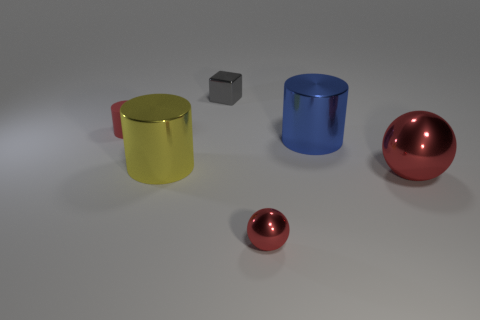What color is the cube that is the same size as the red rubber object?
Provide a succinct answer. Gray. How many things are in front of the tiny metallic block and on the left side of the big ball?
Your response must be concise. 4. What is the small cylinder made of?
Ensure brevity in your answer.  Rubber. How many things are blue matte spheres or tiny gray shiny blocks?
Your response must be concise. 1. Is the size of the red object that is behind the big yellow cylinder the same as the shiny sphere to the left of the large red ball?
Make the answer very short. Yes. How many other objects are there of the same size as the blue cylinder?
Your answer should be very brief. 2. How many objects are either tiny objects that are in front of the small matte object or things that are behind the large blue metallic cylinder?
Offer a terse response. 3. Is the large yellow object made of the same material as the large red sphere that is right of the tiny gray metallic thing?
Provide a short and direct response. Yes. How many other things are there of the same shape as the gray thing?
Your answer should be very brief. 0. What material is the small red thing that is in front of the matte object on the left side of the small shiny thing that is in front of the big blue cylinder?
Provide a succinct answer. Metal. 